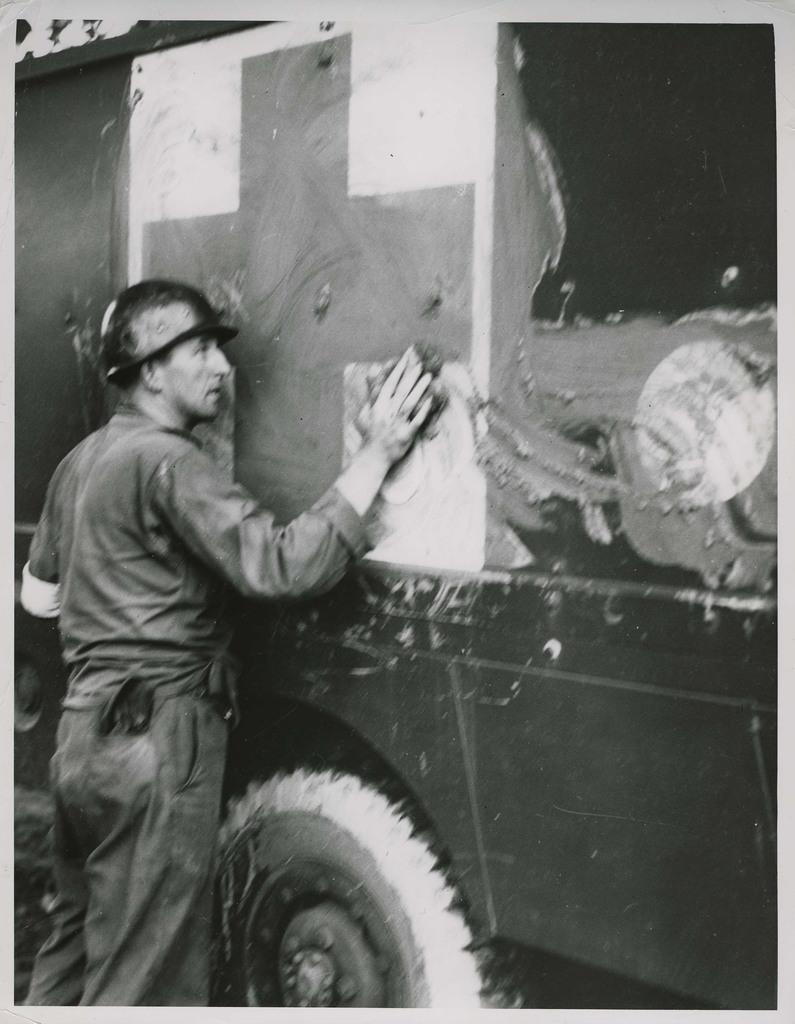What is the main subject of the image? There is a person in the image. What is the person doing in the image? The person is cleaning a vehicle. What tool is the person using to clean the vehicle? The person is using a cloth to clean the vehicle. How many ducks are visible in the image? There are no ducks present in the image. What type of guide is the person using to clean the vehicle? There is no guide present in the image; the person is using a cloth to clean the vehicle. 